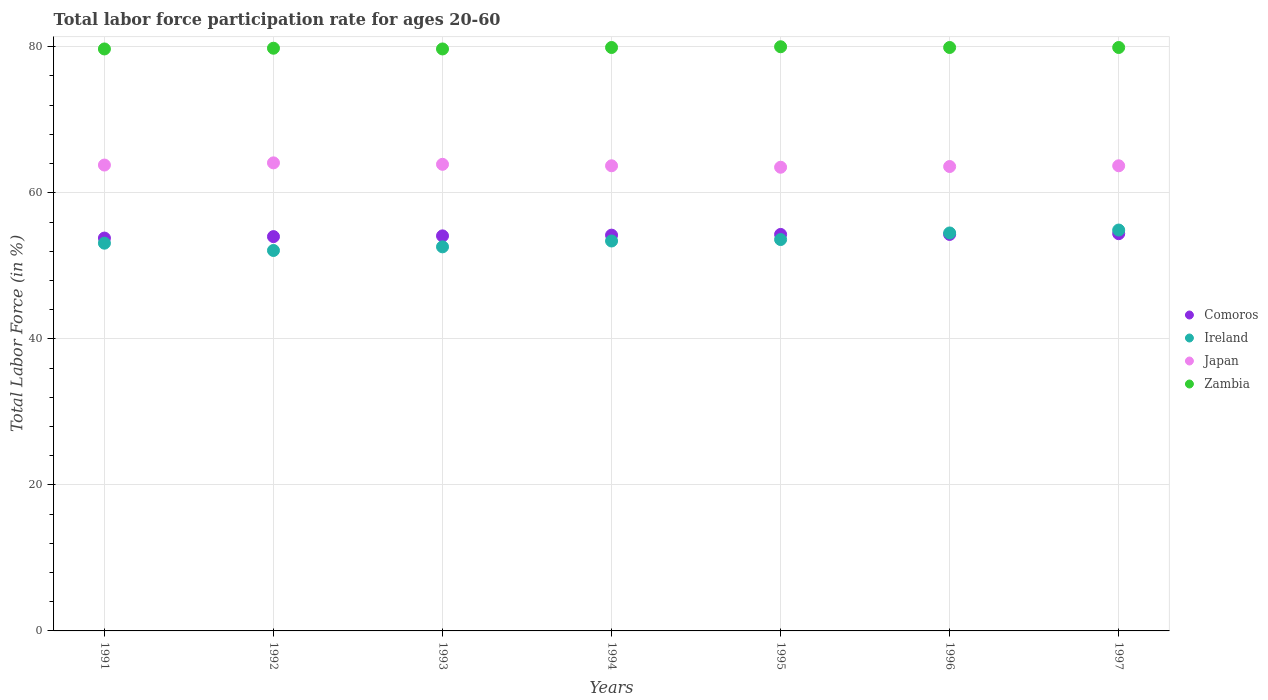How many different coloured dotlines are there?
Your answer should be compact. 4. What is the labor force participation rate in Comoros in 1995?
Keep it short and to the point. 54.3. Across all years, what is the minimum labor force participation rate in Comoros?
Make the answer very short. 53.8. In which year was the labor force participation rate in Zambia maximum?
Provide a succinct answer. 1995. In which year was the labor force participation rate in Japan minimum?
Give a very brief answer. 1995. What is the total labor force participation rate in Japan in the graph?
Make the answer very short. 446.3. What is the difference between the labor force participation rate in Japan in 1994 and that in 1997?
Your answer should be very brief. 0. What is the difference between the labor force participation rate in Ireland in 1994 and the labor force participation rate in Japan in 1995?
Keep it short and to the point. -10.1. What is the average labor force participation rate in Zambia per year?
Your response must be concise. 79.84. In how many years, is the labor force participation rate in Zambia greater than 48 %?
Provide a succinct answer. 7. What is the ratio of the labor force participation rate in Ireland in 1993 to that in 1994?
Make the answer very short. 0.99. Is the difference between the labor force participation rate in Comoros in 1994 and 1997 greater than the difference between the labor force participation rate in Japan in 1994 and 1997?
Give a very brief answer. No. What is the difference between the highest and the second highest labor force participation rate in Zambia?
Ensure brevity in your answer.  0.1. What is the difference between the highest and the lowest labor force participation rate in Japan?
Your answer should be very brief. 0.6. In how many years, is the labor force participation rate in Japan greater than the average labor force participation rate in Japan taken over all years?
Make the answer very short. 3. Is it the case that in every year, the sum of the labor force participation rate in Comoros and labor force participation rate in Japan  is greater than the sum of labor force participation rate in Zambia and labor force participation rate in Ireland?
Give a very brief answer. No. Does the labor force participation rate in Comoros monotonically increase over the years?
Provide a succinct answer. No. Is the labor force participation rate in Japan strictly less than the labor force participation rate in Zambia over the years?
Give a very brief answer. Yes. How many dotlines are there?
Offer a very short reply. 4. How many years are there in the graph?
Provide a short and direct response. 7. What is the difference between two consecutive major ticks on the Y-axis?
Keep it short and to the point. 20. Does the graph contain grids?
Keep it short and to the point. Yes. Where does the legend appear in the graph?
Provide a short and direct response. Center right. What is the title of the graph?
Offer a terse response. Total labor force participation rate for ages 20-60. Does "Europe(all income levels)" appear as one of the legend labels in the graph?
Offer a very short reply. No. What is the label or title of the X-axis?
Give a very brief answer. Years. What is the label or title of the Y-axis?
Your answer should be very brief. Total Labor Force (in %). What is the Total Labor Force (in %) of Comoros in 1991?
Make the answer very short. 53.8. What is the Total Labor Force (in %) of Ireland in 1991?
Make the answer very short. 53.1. What is the Total Labor Force (in %) of Japan in 1991?
Give a very brief answer. 63.8. What is the Total Labor Force (in %) in Zambia in 1991?
Ensure brevity in your answer.  79.7. What is the Total Labor Force (in %) in Comoros in 1992?
Ensure brevity in your answer.  54. What is the Total Labor Force (in %) of Ireland in 1992?
Provide a succinct answer. 52.1. What is the Total Labor Force (in %) in Japan in 1992?
Your answer should be very brief. 64.1. What is the Total Labor Force (in %) in Zambia in 1992?
Provide a succinct answer. 79.8. What is the Total Labor Force (in %) of Comoros in 1993?
Ensure brevity in your answer.  54.1. What is the Total Labor Force (in %) in Ireland in 1993?
Your answer should be compact. 52.6. What is the Total Labor Force (in %) of Japan in 1993?
Your answer should be compact. 63.9. What is the Total Labor Force (in %) of Zambia in 1993?
Offer a terse response. 79.7. What is the Total Labor Force (in %) in Comoros in 1994?
Give a very brief answer. 54.2. What is the Total Labor Force (in %) in Ireland in 1994?
Your answer should be very brief. 53.4. What is the Total Labor Force (in %) of Japan in 1994?
Your response must be concise. 63.7. What is the Total Labor Force (in %) of Zambia in 1994?
Your answer should be compact. 79.9. What is the Total Labor Force (in %) of Comoros in 1995?
Make the answer very short. 54.3. What is the Total Labor Force (in %) of Ireland in 1995?
Your response must be concise. 53.6. What is the Total Labor Force (in %) in Japan in 1995?
Your answer should be compact. 63.5. What is the Total Labor Force (in %) of Comoros in 1996?
Your answer should be compact. 54.3. What is the Total Labor Force (in %) in Ireland in 1996?
Your answer should be compact. 54.5. What is the Total Labor Force (in %) in Japan in 1996?
Offer a terse response. 63.6. What is the Total Labor Force (in %) of Zambia in 1996?
Provide a succinct answer. 79.9. What is the Total Labor Force (in %) in Comoros in 1997?
Your answer should be very brief. 54.4. What is the Total Labor Force (in %) in Ireland in 1997?
Give a very brief answer. 54.9. What is the Total Labor Force (in %) in Japan in 1997?
Your answer should be very brief. 63.7. What is the Total Labor Force (in %) of Zambia in 1997?
Make the answer very short. 79.9. Across all years, what is the maximum Total Labor Force (in %) of Comoros?
Provide a succinct answer. 54.4. Across all years, what is the maximum Total Labor Force (in %) in Ireland?
Provide a succinct answer. 54.9. Across all years, what is the maximum Total Labor Force (in %) of Japan?
Provide a succinct answer. 64.1. Across all years, what is the minimum Total Labor Force (in %) of Comoros?
Your answer should be compact. 53.8. Across all years, what is the minimum Total Labor Force (in %) of Ireland?
Give a very brief answer. 52.1. Across all years, what is the minimum Total Labor Force (in %) in Japan?
Your response must be concise. 63.5. Across all years, what is the minimum Total Labor Force (in %) of Zambia?
Your answer should be compact. 79.7. What is the total Total Labor Force (in %) in Comoros in the graph?
Provide a succinct answer. 379.1. What is the total Total Labor Force (in %) of Ireland in the graph?
Your answer should be compact. 374.2. What is the total Total Labor Force (in %) in Japan in the graph?
Offer a very short reply. 446.3. What is the total Total Labor Force (in %) of Zambia in the graph?
Offer a very short reply. 558.9. What is the difference between the Total Labor Force (in %) of Comoros in 1991 and that in 1993?
Make the answer very short. -0.3. What is the difference between the Total Labor Force (in %) of Ireland in 1991 and that in 1993?
Provide a short and direct response. 0.5. What is the difference between the Total Labor Force (in %) in Ireland in 1991 and that in 1994?
Ensure brevity in your answer.  -0.3. What is the difference between the Total Labor Force (in %) in Zambia in 1991 and that in 1994?
Your response must be concise. -0.2. What is the difference between the Total Labor Force (in %) of Comoros in 1991 and that in 1995?
Offer a terse response. -0.5. What is the difference between the Total Labor Force (in %) of Comoros in 1991 and that in 1996?
Your answer should be compact. -0.5. What is the difference between the Total Labor Force (in %) of Japan in 1991 and that in 1996?
Your answer should be very brief. 0.2. What is the difference between the Total Labor Force (in %) of Comoros in 1991 and that in 1997?
Provide a succinct answer. -0.6. What is the difference between the Total Labor Force (in %) in Japan in 1992 and that in 1993?
Provide a succinct answer. 0.2. What is the difference between the Total Labor Force (in %) in Ireland in 1992 and that in 1995?
Offer a very short reply. -1.5. What is the difference between the Total Labor Force (in %) of Japan in 1992 and that in 1995?
Give a very brief answer. 0.6. What is the difference between the Total Labor Force (in %) in Zambia in 1992 and that in 1995?
Offer a very short reply. -0.2. What is the difference between the Total Labor Force (in %) of Comoros in 1992 and that in 1996?
Your answer should be very brief. -0.3. What is the difference between the Total Labor Force (in %) in Ireland in 1992 and that in 1996?
Your response must be concise. -2.4. What is the difference between the Total Labor Force (in %) in Zambia in 1992 and that in 1996?
Keep it short and to the point. -0.1. What is the difference between the Total Labor Force (in %) of Comoros in 1992 and that in 1997?
Make the answer very short. -0.4. What is the difference between the Total Labor Force (in %) of Ireland in 1992 and that in 1997?
Keep it short and to the point. -2.8. What is the difference between the Total Labor Force (in %) of Japan in 1992 and that in 1997?
Your response must be concise. 0.4. What is the difference between the Total Labor Force (in %) of Japan in 1993 and that in 1994?
Your answer should be very brief. 0.2. What is the difference between the Total Labor Force (in %) of Zambia in 1993 and that in 1994?
Your response must be concise. -0.2. What is the difference between the Total Labor Force (in %) in Ireland in 1993 and that in 1995?
Give a very brief answer. -1. What is the difference between the Total Labor Force (in %) in Japan in 1993 and that in 1995?
Provide a short and direct response. 0.4. What is the difference between the Total Labor Force (in %) in Ireland in 1993 and that in 1996?
Your answer should be compact. -1.9. What is the difference between the Total Labor Force (in %) of Zambia in 1993 and that in 1996?
Your answer should be compact. -0.2. What is the difference between the Total Labor Force (in %) of Zambia in 1993 and that in 1997?
Make the answer very short. -0.2. What is the difference between the Total Labor Force (in %) in Japan in 1994 and that in 1995?
Your response must be concise. 0.2. What is the difference between the Total Labor Force (in %) of Zambia in 1994 and that in 1995?
Keep it short and to the point. -0.1. What is the difference between the Total Labor Force (in %) of Ireland in 1994 and that in 1996?
Ensure brevity in your answer.  -1.1. What is the difference between the Total Labor Force (in %) of Comoros in 1994 and that in 1997?
Your answer should be very brief. -0.2. What is the difference between the Total Labor Force (in %) of Ireland in 1994 and that in 1997?
Your response must be concise. -1.5. What is the difference between the Total Labor Force (in %) in Japan in 1994 and that in 1997?
Give a very brief answer. 0. What is the difference between the Total Labor Force (in %) in Comoros in 1995 and that in 1996?
Your response must be concise. 0. What is the difference between the Total Labor Force (in %) of Ireland in 1995 and that in 1996?
Your answer should be compact. -0.9. What is the difference between the Total Labor Force (in %) of Zambia in 1995 and that in 1996?
Ensure brevity in your answer.  0.1. What is the difference between the Total Labor Force (in %) of Comoros in 1995 and that in 1997?
Keep it short and to the point. -0.1. What is the difference between the Total Labor Force (in %) in Ireland in 1995 and that in 1997?
Your answer should be very brief. -1.3. What is the difference between the Total Labor Force (in %) in Japan in 1995 and that in 1997?
Your response must be concise. -0.2. What is the difference between the Total Labor Force (in %) in Zambia in 1995 and that in 1997?
Ensure brevity in your answer.  0.1. What is the difference between the Total Labor Force (in %) in Japan in 1996 and that in 1997?
Keep it short and to the point. -0.1. What is the difference between the Total Labor Force (in %) in Comoros in 1991 and the Total Labor Force (in %) in Japan in 1992?
Your response must be concise. -10.3. What is the difference between the Total Labor Force (in %) of Comoros in 1991 and the Total Labor Force (in %) of Zambia in 1992?
Your answer should be compact. -26. What is the difference between the Total Labor Force (in %) in Ireland in 1991 and the Total Labor Force (in %) in Japan in 1992?
Offer a terse response. -11. What is the difference between the Total Labor Force (in %) of Ireland in 1991 and the Total Labor Force (in %) of Zambia in 1992?
Offer a very short reply. -26.7. What is the difference between the Total Labor Force (in %) of Japan in 1991 and the Total Labor Force (in %) of Zambia in 1992?
Your response must be concise. -16. What is the difference between the Total Labor Force (in %) in Comoros in 1991 and the Total Labor Force (in %) in Zambia in 1993?
Your answer should be compact. -25.9. What is the difference between the Total Labor Force (in %) in Ireland in 1991 and the Total Labor Force (in %) in Japan in 1993?
Your response must be concise. -10.8. What is the difference between the Total Labor Force (in %) of Ireland in 1991 and the Total Labor Force (in %) of Zambia in 1993?
Give a very brief answer. -26.6. What is the difference between the Total Labor Force (in %) in Japan in 1991 and the Total Labor Force (in %) in Zambia in 1993?
Offer a terse response. -15.9. What is the difference between the Total Labor Force (in %) in Comoros in 1991 and the Total Labor Force (in %) in Ireland in 1994?
Your answer should be compact. 0.4. What is the difference between the Total Labor Force (in %) of Comoros in 1991 and the Total Labor Force (in %) of Japan in 1994?
Your response must be concise. -9.9. What is the difference between the Total Labor Force (in %) of Comoros in 1991 and the Total Labor Force (in %) of Zambia in 1994?
Provide a succinct answer. -26.1. What is the difference between the Total Labor Force (in %) of Ireland in 1991 and the Total Labor Force (in %) of Zambia in 1994?
Give a very brief answer. -26.8. What is the difference between the Total Labor Force (in %) of Japan in 1991 and the Total Labor Force (in %) of Zambia in 1994?
Your response must be concise. -16.1. What is the difference between the Total Labor Force (in %) of Comoros in 1991 and the Total Labor Force (in %) of Japan in 1995?
Give a very brief answer. -9.7. What is the difference between the Total Labor Force (in %) of Comoros in 1991 and the Total Labor Force (in %) of Zambia in 1995?
Your answer should be compact. -26.2. What is the difference between the Total Labor Force (in %) of Ireland in 1991 and the Total Labor Force (in %) of Japan in 1995?
Keep it short and to the point. -10.4. What is the difference between the Total Labor Force (in %) of Ireland in 1991 and the Total Labor Force (in %) of Zambia in 1995?
Provide a succinct answer. -26.9. What is the difference between the Total Labor Force (in %) in Japan in 1991 and the Total Labor Force (in %) in Zambia in 1995?
Give a very brief answer. -16.2. What is the difference between the Total Labor Force (in %) in Comoros in 1991 and the Total Labor Force (in %) in Ireland in 1996?
Your answer should be compact. -0.7. What is the difference between the Total Labor Force (in %) of Comoros in 1991 and the Total Labor Force (in %) of Japan in 1996?
Your answer should be very brief. -9.8. What is the difference between the Total Labor Force (in %) in Comoros in 1991 and the Total Labor Force (in %) in Zambia in 1996?
Your answer should be compact. -26.1. What is the difference between the Total Labor Force (in %) in Ireland in 1991 and the Total Labor Force (in %) in Zambia in 1996?
Offer a terse response. -26.8. What is the difference between the Total Labor Force (in %) in Japan in 1991 and the Total Labor Force (in %) in Zambia in 1996?
Your answer should be very brief. -16.1. What is the difference between the Total Labor Force (in %) in Comoros in 1991 and the Total Labor Force (in %) in Ireland in 1997?
Keep it short and to the point. -1.1. What is the difference between the Total Labor Force (in %) in Comoros in 1991 and the Total Labor Force (in %) in Japan in 1997?
Your answer should be compact. -9.9. What is the difference between the Total Labor Force (in %) in Comoros in 1991 and the Total Labor Force (in %) in Zambia in 1997?
Your answer should be very brief. -26.1. What is the difference between the Total Labor Force (in %) in Ireland in 1991 and the Total Labor Force (in %) in Japan in 1997?
Give a very brief answer. -10.6. What is the difference between the Total Labor Force (in %) of Ireland in 1991 and the Total Labor Force (in %) of Zambia in 1997?
Keep it short and to the point. -26.8. What is the difference between the Total Labor Force (in %) of Japan in 1991 and the Total Labor Force (in %) of Zambia in 1997?
Give a very brief answer. -16.1. What is the difference between the Total Labor Force (in %) of Comoros in 1992 and the Total Labor Force (in %) of Ireland in 1993?
Provide a short and direct response. 1.4. What is the difference between the Total Labor Force (in %) of Comoros in 1992 and the Total Labor Force (in %) of Zambia in 1993?
Offer a terse response. -25.7. What is the difference between the Total Labor Force (in %) in Ireland in 1992 and the Total Labor Force (in %) in Zambia in 1993?
Your answer should be very brief. -27.6. What is the difference between the Total Labor Force (in %) of Japan in 1992 and the Total Labor Force (in %) of Zambia in 1993?
Provide a short and direct response. -15.6. What is the difference between the Total Labor Force (in %) in Comoros in 1992 and the Total Labor Force (in %) in Ireland in 1994?
Your response must be concise. 0.6. What is the difference between the Total Labor Force (in %) of Comoros in 1992 and the Total Labor Force (in %) of Zambia in 1994?
Your answer should be very brief. -25.9. What is the difference between the Total Labor Force (in %) in Ireland in 1992 and the Total Labor Force (in %) in Japan in 1994?
Provide a short and direct response. -11.6. What is the difference between the Total Labor Force (in %) of Ireland in 1992 and the Total Labor Force (in %) of Zambia in 1994?
Provide a succinct answer. -27.8. What is the difference between the Total Labor Force (in %) of Japan in 1992 and the Total Labor Force (in %) of Zambia in 1994?
Your answer should be very brief. -15.8. What is the difference between the Total Labor Force (in %) of Comoros in 1992 and the Total Labor Force (in %) of Ireland in 1995?
Your response must be concise. 0.4. What is the difference between the Total Labor Force (in %) of Comoros in 1992 and the Total Labor Force (in %) of Zambia in 1995?
Provide a succinct answer. -26. What is the difference between the Total Labor Force (in %) of Ireland in 1992 and the Total Labor Force (in %) of Japan in 1995?
Keep it short and to the point. -11.4. What is the difference between the Total Labor Force (in %) in Ireland in 1992 and the Total Labor Force (in %) in Zambia in 1995?
Provide a succinct answer. -27.9. What is the difference between the Total Labor Force (in %) of Japan in 1992 and the Total Labor Force (in %) of Zambia in 1995?
Provide a short and direct response. -15.9. What is the difference between the Total Labor Force (in %) of Comoros in 1992 and the Total Labor Force (in %) of Ireland in 1996?
Offer a terse response. -0.5. What is the difference between the Total Labor Force (in %) of Comoros in 1992 and the Total Labor Force (in %) of Japan in 1996?
Your answer should be very brief. -9.6. What is the difference between the Total Labor Force (in %) of Comoros in 1992 and the Total Labor Force (in %) of Zambia in 1996?
Offer a terse response. -25.9. What is the difference between the Total Labor Force (in %) in Ireland in 1992 and the Total Labor Force (in %) in Zambia in 1996?
Your answer should be compact. -27.8. What is the difference between the Total Labor Force (in %) of Japan in 1992 and the Total Labor Force (in %) of Zambia in 1996?
Ensure brevity in your answer.  -15.8. What is the difference between the Total Labor Force (in %) in Comoros in 1992 and the Total Labor Force (in %) in Ireland in 1997?
Give a very brief answer. -0.9. What is the difference between the Total Labor Force (in %) in Comoros in 1992 and the Total Labor Force (in %) in Japan in 1997?
Keep it short and to the point. -9.7. What is the difference between the Total Labor Force (in %) of Comoros in 1992 and the Total Labor Force (in %) of Zambia in 1997?
Offer a terse response. -25.9. What is the difference between the Total Labor Force (in %) of Ireland in 1992 and the Total Labor Force (in %) of Japan in 1997?
Provide a short and direct response. -11.6. What is the difference between the Total Labor Force (in %) in Ireland in 1992 and the Total Labor Force (in %) in Zambia in 1997?
Offer a very short reply. -27.8. What is the difference between the Total Labor Force (in %) in Japan in 1992 and the Total Labor Force (in %) in Zambia in 1997?
Your answer should be compact. -15.8. What is the difference between the Total Labor Force (in %) in Comoros in 1993 and the Total Labor Force (in %) in Zambia in 1994?
Your answer should be very brief. -25.8. What is the difference between the Total Labor Force (in %) in Ireland in 1993 and the Total Labor Force (in %) in Japan in 1994?
Keep it short and to the point. -11.1. What is the difference between the Total Labor Force (in %) of Ireland in 1993 and the Total Labor Force (in %) of Zambia in 1994?
Offer a very short reply. -27.3. What is the difference between the Total Labor Force (in %) of Japan in 1993 and the Total Labor Force (in %) of Zambia in 1994?
Keep it short and to the point. -16. What is the difference between the Total Labor Force (in %) in Comoros in 1993 and the Total Labor Force (in %) in Ireland in 1995?
Make the answer very short. 0.5. What is the difference between the Total Labor Force (in %) of Comoros in 1993 and the Total Labor Force (in %) of Japan in 1995?
Offer a terse response. -9.4. What is the difference between the Total Labor Force (in %) of Comoros in 1993 and the Total Labor Force (in %) of Zambia in 1995?
Give a very brief answer. -25.9. What is the difference between the Total Labor Force (in %) in Ireland in 1993 and the Total Labor Force (in %) in Zambia in 1995?
Your answer should be compact. -27.4. What is the difference between the Total Labor Force (in %) of Japan in 1993 and the Total Labor Force (in %) of Zambia in 1995?
Make the answer very short. -16.1. What is the difference between the Total Labor Force (in %) of Comoros in 1993 and the Total Labor Force (in %) of Ireland in 1996?
Ensure brevity in your answer.  -0.4. What is the difference between the Total Labor Force (in %) of Comoros in 1993 and the Total Labor Force (in %) of Japan in 1996?
Your answer should be compact. -9.5. What is the difference between the Total Labor Force (in %) in Comoros in 1993 and the Total Labor Force (in %) in Zambia in 1996?
Offer a very short reply. -25.8. What is the difference between the Total Labor Force (in %) of Ireland in 1993 and the Total Labor Force (in %) of Zambia in 1996?
Provide a short and direct response. -27.3. What is the difference between the Total Labor Force (in %) of Comoros in 1993 and the Total Labor Force (in %) of Ireland in 1997?
Provide a short and direct response. -0.8. What is the difference between the Total Labor Force (in %) in Comoros in 1993 and the Total Labor Force (in %) in Japan in 1997?
Make the answer very short. -9.6. What is the difference between the Total Labor Force (in %) of Comoros in 1993 and the Total Labor Force (in %) of Zambia in 1997?
Provide a succinct answer. -25.8. What is the difference between the Total Labor Force (in %) in Ireland in 1993 and the Total Labor Force (in %) in Japan in 1997?
Make the answer very short. -11.1. What is the difference between the Total Labor Force (in %) in Ireland in 1993 and the Total Labor Force (in %) in Zambia in 1997?
Offer a very short reply. -27.3. What is the difference between the Total Labor Force (in %) in Comoros in 1994 and the Total Labor Force (in %) in Zambia in 1995?
Keep it short and to the point. -25.8. What is the difference between the Total Labor Force (in %) in Ireland in 1994 and the Total Labor Force (in %) in Japan in 1995?
Provide a short and direct response. -10.1. What is the difference between the Total Labor Force (in %) in Ireland in 1994 and the Total Labor Force (in %) in Zambia in 1995?
Provide a short and direct response. -26.6. What is the difference between the Total Labor Force (in %) in Japan in 1994 and the Total Labor Force (in %) in Zambia in 1995?
Ensure brevity in your answer.  -16.3. What is the difference between the Total Labor Force (in %) of Comoros in 1994 and the Total Labor Force (in %) of Ireland in 1996?
Offer a very short reply. -0.3. What is the difference between the Total Labor Force (in %) of Comoros in 1994 and the Total Labor Force (in %) of Zambia in 1996?
Make the answer very short. -25.7. What is the difference between the Total Labor Force (in %) in Ireland in 1994 and the Total Labor Force (in %) in Zambia in 1996?
Provide a short and direct response. -26.5. What is the difference between the Total Labor Force (in %) in Japan in 1994 and the Total Labor Force (in %) in Zambia in 1996?
Your answer should be very brief. -16.2. What is the difference between the Total Labor Force (in %) in Comoros in 1994 and the Total Labor Force (in %) in Japan in 1997?
Offer a very short reply. -9.5. What is the difference between the Total Labor Force (in %) in Comoros in 1994 and the Total Labor Force (in %) in Zambia in 1997?
Ensure brevity in your answer.  -25.7. What is the difference between the Total Labor Force (in %) in Ireland in 1994 and the Total Labor Force (in %) in Japan in 1997?
Your answer should be very brief. -10.3. What is the difference between the Total Labor Force (in %) of Ireland in 1994 and the Total Labor Force (in %) of Zambia in 1997?
Your answer should be very brief. -26.5. What is the difference between the Total Labor Force (in %) of Japan in 1994 and the Total Labor Force (in %) of Zambia in 1997?
Ensure brevity in your answer.  -16.2. What is the difference between the Total Labor Force (in %) in Comoros in 1995 and the Total Labor Force (in %) in Ireland in 1996?
Make the answer very short. -0.2. What is the difference between the Total Labor Force (in %) of Comoros in 1995 and the Total Labor Force (in %) of Japan in 1996?
Offer a terse response. -9.3. What is the difference between the Total Labor Force (in %) in Comoros in 1995 and the Total Labor Force (in %) in Zambia in 1996?
Offer a very short reply. -25.6. What is the difference between the Total Labor Force (in %) of Ireland in 1995 and the Total Labor Force (in %) of Zambia in 1996?
Give a very brief answer. -26.3. What is the difference between the Total Labor Force (in %) in Japan in 1995 and the Total Labor Force (in %) in Zambia in 1996?
Make the answer very short. -16.4. What is the difference between the Total Labor Force (in %) of Comoros in 1995 and the Total Labor Force (in %) of Ireland in 1997?
Your answer should be very brief. -0.6. What is the difference between the Total Labor Force (in %) of Comoros in 1995 and the Total Labor Force (in %) of Zambia in 1997?
Keep it short and to the point. -25.6. What is the difference between the Total Labor Force (in %) in Ireland in 1995 and the Total Labor Force (in %) in Japan in 1997?
Give a very brief answer. -10.1. What is the difference between the Total Labor Force (in %) of Ireland in 1995 and the Total Labor Force (in %) of Zambia in 1997?
Your response must be concise. -26.3. What is the difference between the Total Labor Force (in %) in Japan in 1995 and the Total Labor Force (in %) in Zambia in 1997?
Provide a short and direct response. -16.4. What is the difference between the Total Labor Force (in %) in Comoros in 1996 and the Total Labor Force (in %) in Zambia in 1997?
Provide a short and direct response. -25.6. What is the difference between the Total Labor Force (in %) in Ireland in 1996 and the Total Labor Force (in %) in Japan in 1997?
Your response must be concise. -9.2. What is the difference between the Total Labor Force (in %) of Ireland in 1996 and the Total Labor Force (in %) of Zambia in 1997?
Make the answer very short. -25.4. What is the difference between the Total Labor Force (in %) of Japan in 1996 and the Total Labor Force (in %) of Zambia in 1997?
Provide a succinct answer. -16.3. What is the average Total Labor Force (in %) of Comoros per year?
Give a very brief answer. 54.16. What is the average Total Labor Force (in %) of Ireland per year?
Offer a very short reply. 53.46. What is the average Total Labor Force (in %) of Japan per year?
Give a very brief answer. 63.76. What is the average Total Labor Force (in %) in Zambia per year?
Give a very brief answer. 79.84. In the year 1991, what is the difference between the Total Labor Force (in %) of Comoros and Total Labor Force (in %) of Ireland?
Your answer should be compact. 0.7. In the year 1991, what is the difference between the Total Labor Force (in %) of Comoros and Total Labor Force (in %) of Japan?
Ensure brevity in your answer.  -10. In the year 1991, what is the difference between the Total Labor Force (in %) of Comoros and Total Labor Force (in %) of Zambia?
Offer a terse response. -25.9. In the year 1991, what is the difference between the Total Labor Force (in %) in Ireland and Total Labor Force (in %) in Zambia?
Your response must be concise. -26.6. In the year 1991, what is the difference between the Total Labor Force (in %) in Japan and Total Labor Force (in %) in Zambia?
Ensure brevity in your answer.  -15.9. In the year 1992, what is the difference between the Total Labor Force (in %) in Comoros and Total Labor Force (in %) in Japan?
Your answer should be very brief. -10.1. In the year 1992, what is the difference between the Total Labor Force (in %) in Comoros and Total Labor Force (in %) in Zambia?
Your response must be concise. -25.8. In the year 1992, what is the difference between the Total Labor Force (in %) in Ireland and Total Labor Force (in %) in Japan?
Offer a very short reply. -12. In the year 1992, what is the difference between the Total Labor Force (in %) in Ireland and Total Labor Force (in %) in Zambia?
Your answer should be compact. -27.7. In the year 1992, what is the difference between the Total Labor Force (in %) in Japan and Total Labor Force (in %) in Zambia?
Ensure brevity in your answer.  -15.7. In the year 1993, what is the difference between the Total Labor Force (in %) in Comoros and Total Labor Force (in %) in Ireland?
Your response must be concise. 1.5. In the year 1993, what is the difference between the Total Labor Force (in %) in Comoros and Total Labor Force (in %) in Zambia?
Offer a very short reply. -25.6. In the year 1993, what is the difference between the Total Labor Force (in %) of Ireland and Total Labor Force (in %) of Zambia?
Offer a very short reply. -27.1. In the year 1993, what is the difference between the Total Labor Force (in %) of Japan and Total Labor Force (in %) of Zambia?
Keep it short and to the point. -15.8. In the year 1994, what is the difference between the Total Labor Force (in %) of Comoros and Total Labor Force (in %) of Ireland?
Give a very brief answer. 0.8. In the year 1994, what is the difference between the Total Labor Force (in %) in Comoros and Total Labor Force (in %) in Japan?
Make the answer very short. -9.5. In the year 1994, what is the difference between the Total Labor Force (in %) in Comoros and Total Labor Force (in %) in Zambia?
Your answer should be compact. -25.7. In the year 1994, what is the difference between the Total Labor Force (in %) of Ireland and Total Labor Force (in %) of Japan?
Make the answer very short. -10.3. In the year 1994, what is the difference between the Total Labor Force (in %) in Ireland and Total Labor Force (in %) in Zambia?
Provide a short and direct response. -26.5. In the year 1994, what is the difference between the Total Labor Force (in %) in Japan and Total Labor Force (in %) in Zambia?
Your response must be concise. -16.2. In the year 1995, what is the difference between the Total Labor Force (in %) in Comoros and Total Labor Force (in %) in Zambia?
Offer a terse response. -25.7. In the year 1995, what is the difference between the Total Labor Force (in %) of Ireland and Total Labor Force (in %) of Japan?
Your answer should be very brief. -9.9. In the year 1995, what is the difference between the Total Labor Force (in %) in Ireland and Total Labor Force (in %) in Zambia?
Keep it short and to the point. -26.4. In the year 1995, what is the difference between the Total Labor Force (in %) in Japan and Total Labor Force (in %) in Zambia?
Keep it short and to the point. -16.5. In the year 1996, what is the difference between the Total Labor Force (in %) in Comoros and Total Labor Force (in %) in Ireland?
Offer a very short reply. -0.2. In the year 1996, what is the difference between the Total Labor Force (in %) of Comoros and Total Labor Force (in %) of Japan?
Your answer should be very brief. -9.3. In the year 1996, what is the difference between the Total Labor Force (in %) of Comoros and Total Labor Force (in %) of Zambia?
Your answer should be compact. -25.6. In the year 1996, what is the difference between the Total Labor Force (in %) of Ireland and Total Labor Force (in %) of Zambia?
Give a very brief answer. -25.4. In the year 1996, what is the difference between the Total Labor Force (in %) of Japan and Total Labor Force (in %) of Zambia?
Keep it short and to the point. -16.3. In the year 1997, what is the difference between the Total Labor Force (in %) in Comoros and Total Labor Force (in %) in Ireland?
Ensure brevity in your answer.  -0.5. In the year 1997, what is the difference between the Total Labor Force (in %) of Comoros and Total Labor Force (in %) of Japan?
Your response must be concise. -9.3. In the year 1997, what is the difference between the Total Labor Force (in %) in Comoros and Total Labor Force (in %) in Zambia?
Make the answer very short. -25.5. In the year 1997, what is the difference between the Total Labor Force (in %) in Ireland and Total Labor Force (in %) in Zambia?
Your response must be concise. -25. In the year 1997, what is the difference between the Total Labor Force (in %) of Japan and Total Labor Force (in %) of Zambia?
Provide a short and direct response. -16.2. What is the ratio of the Total Labor Force (in %) of Ireland in 1991 to that in 1992?
Give a very brief answer. 1.02. What is the ratio of the Total Labor Force (in %) in Japan in 1991 to that in 1992?
Your answer should be very brief. 1. What is the ratio of the Total Labor Force (in %) of Zambia in 1991 to that in 1992?
Make the answer very short. 1. What is the ratio of the Total Labor Force (in %) of Ireland in 1991 to that in 1993?
Provide a succinct answer. 1.01. What is the ratio of the Total Labor Force (in %) in Japan in 1991 to that in 1993?
Your response must be concise. 1. What is the ratio of the Total Labor Force (in %) in Ireland in 1991 to that in 1994?
Make the answer very short. 0.99. What is the ratio of the Total Labor Force (in %) of Zambia in 1991 to that in 1995?
Ensure brevity in your answer.  1. What is the ratio of the Total Labor Force (in %) in Comoros in 1991 to that in 1996?
Your answer should be very brief. 0.99. What is the ratio of the Total Labor Force (in %) of Ireland in 1991 to that in 1996?
Your response must be concise. 0.97. What is the ratio of the Total Labor Force (in %) of Zambia in 1991 to that in 1996?
Offer a very short reply. 1. What is the ratio of the Total Labor Force (in %) in Ireland in 1991 to that in 1997?
Give a very brief answer. 0.97. What is the ratio of the Total Labor Force (in %) of Japan in 1991 to that in 1997?
Keep it short and to the point. 1. What is the ratio of the Total Labor Force (in %) of Japan in 1992 to that in 1993?
Give a very brief answer. 1. What is the ratio of the Total Labor Force (in %) in Comoros in 1992 to that in 1994?
Offer a very short reply. 1. What is the ratio of the Total Labor Force (in %) in Ireland in 1992 to that in 1994?
Give a very brief answer. 0.98. What is the ratio of the Total Labor Force (in %) in Zambia in 1992 to that in 1994?
Offer a very short reply. 1. What is the ratio of the Total Labor Force (in %) of Japan in 1992 to that in 1995?
Offer a terse response. 1.01. What is the ratio of the Total Labor Force (in %) of Zambia in 1992 to that in 1995?
Make the answer very short. 1. What is the ratio of the Total Labor Force (in %) in Comoros in 1992 to that in 1996?
Give a very brief answer. 0.99. What is the ratio of the Total Labor Force (in %) of Ireland in 1992 to that in 1996?
Offer a very short reply. 0.96. What is the ratio of the Total Labor Force (in %) in Japan in 1992 to that in 1996?
Make the answer very short. 1.01. What is the ratio of the Total Labor Force (in %) in Ireland in 1992 to that in 1997?
Give a very brief answer. 0.95. What is the ratio of the Total Labor Force (in %) of Zambia in 1992 to that in 1997?
Provide a short and direct response. 1. What is the ratio of the Total Labor Force (in %) of Comoros in 1993 to that in 1994?
Your response must be concise. 1. What is the ratio of the Total Labor Force (in %) in Ireland in 1993 to that in 1994?
Give a very brief answer. 0.98. What is the ratio of the Total Labor Force (in %) in Japan in 1993 to that in 1994?
Your answer should be compact. 1. What is the ratio of the Total Labor Force (in %) in Zambia in 1993 to that in 1994?
Your answer should be compact. 1. What is the ratio of the Total Labor Force (in %) in Ireland in 1993 to that in 1995?
Provide a succinct answer. 0.98. What is the ratio of the Total Labor Force (in %) in Japan in 1993 to that in 1995?
Give a very brief answer. 1.01. What is the ratio of the Total Labor Force (in %) in Ireland in 1993 to that in 1996?
Your answer should be compact. 0.97. What is the ratio of the Total Labor Force (in %) of Japan in 1993 to that in 1996?
Make the answer very short. 1. What is the ratio of the Total Labor Force (in %) of Zambia in 1993 to that in 1996?
Your response must be concise. 1. What is the ratio of the Total Labor Force (in %) in Comoros in 1993 to that in 1997?
Ensure brevity in your answer.  0.99. What is the ratio of the Total Labor Force (in %) of Ireland in 1993 to that in 1997?
Ensure brevity in your answer.  0.96. What is the ratio of the Total Labor Force (in %) in Japan in 1993 to that in 1997?
Your answer should be very brief. 1. What is the ratio of the Total Labor Force (in %) in Zambia in 1993 to that in 1997?
Ensure brevity in your answer.  1. What is the ratio of the Total Labor Force (in %) of Comoros in 1994 to that in 1995?
Give a very brief answer. 1. What is the ratio of the Total Labor Force (in %) of Japan in 1994 to that in 1995?
Your answer should be compact. 1. What is the ratio of the Total Labor Force (in %) of Comoros in 1994 to that in 1996?
Give a very brief answer. 1. What is the ratio of the Total Labor Force (in %) in Ireland in 1994 to that in 1996?
Your response must be concise. 0.98. What is the ratio of the Total Labor Force (in %) of Comoros in 1994 to that in 1997?
Your answer should be very brief. 1. What is the ratio of the Total Labor Force (in %) in Ireland in 1994 to that in 1997?
Ensure brevity in your answer.  0.97. What is the ratio of the Total Labor Force (in %) of Japan in 1994 to that in 1997?
Your answer should be very brief. 1. What is the ratio of the Total Labor Force (in %) of Ireland in 1995 to that in 1996?
Your response must be concise. 0.98. What is the ratio of the Total Labor Force (in %) in Zambia in 1995 to that in 1996?
Make the answer very short. 1. What is the ratio of the Total Labor Force (in %) in Ireland in 1995 to that in 1997?
Your response must be concise. 0.98. What is the ratio of the Total Labor Force (in %) in Zambia in 1995 to that in 1997?
Keep it short and to the point. 1. What is the ratio of the Total Labor Force (in %) in Japan in 1996 to that in 1997?
Give a very brief answer. 1. What is the difference between the highest and the second highest Total Labor Force (in %) of Comoros?
Keep it short and to the point. 0.1. What is the difference between the highest and the second highest Total Labor Force (in %) of Ireland?
Offer a very short reply. 0.4. What is the difference between the highest and the second highest Total Labor Force (in %) in Japan?
Your answer should be compact. 0.2. What is the difference between the highest and the second highest Total Labor Force (in %) of Zambia?
Keep it short and to the point. 0.1. What is the difference between the highest and the lowest Total Labor Force (in %) of Comoros?
Give a very brief answer. 0.6. What is the difference between the highest and the lowest Total Labor Force (in %) of Japan?
Ensure brevity in your answer.  0.6. What is the difference between the highest and the lowest Total Labor Force (in %) of Zambia?
Make the answer very short. 0.3. 